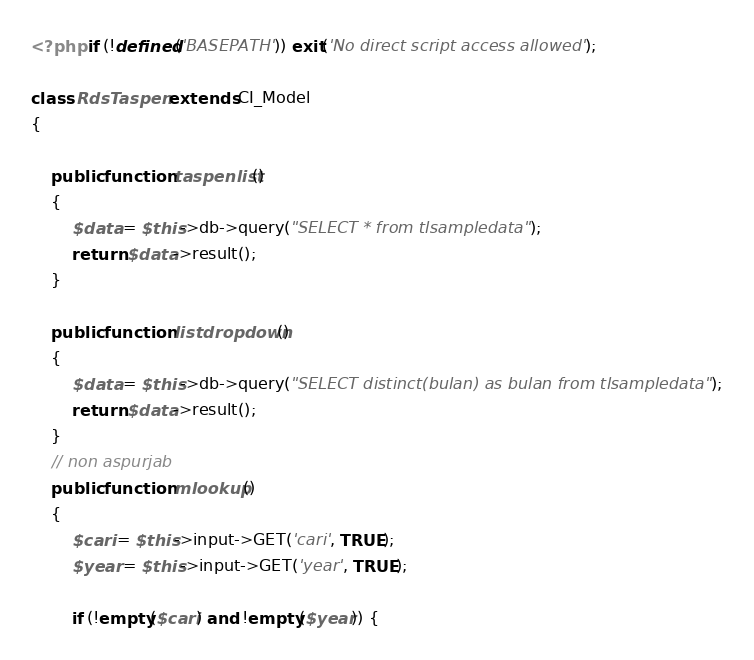<code> <loc_0><loc_0><loc_500><loc_500><_PHP_><?php if (!defined('BASEPATH')) exit('No direct script access allowed');

class RdsTaspen extends CI_Model
{

	public function taspenlist()
	{
		$data = $this->db->query("SELECT * from tlsampledata");
		return $data->result();
	}

	public function listdropdown()
	{
		$data = $this->db->query("SELECT distinct(bulan) as bulan from tlsampledata");
		return $data->result();
	}
	// non aspurjab
	public function mlookup()
	{
		$cari = $this->input->GET('cari', TRUE);
		$year = $this->input->GET('year', TRUE);

		if (!empty($cari) and !empty($year)) {
</code> 